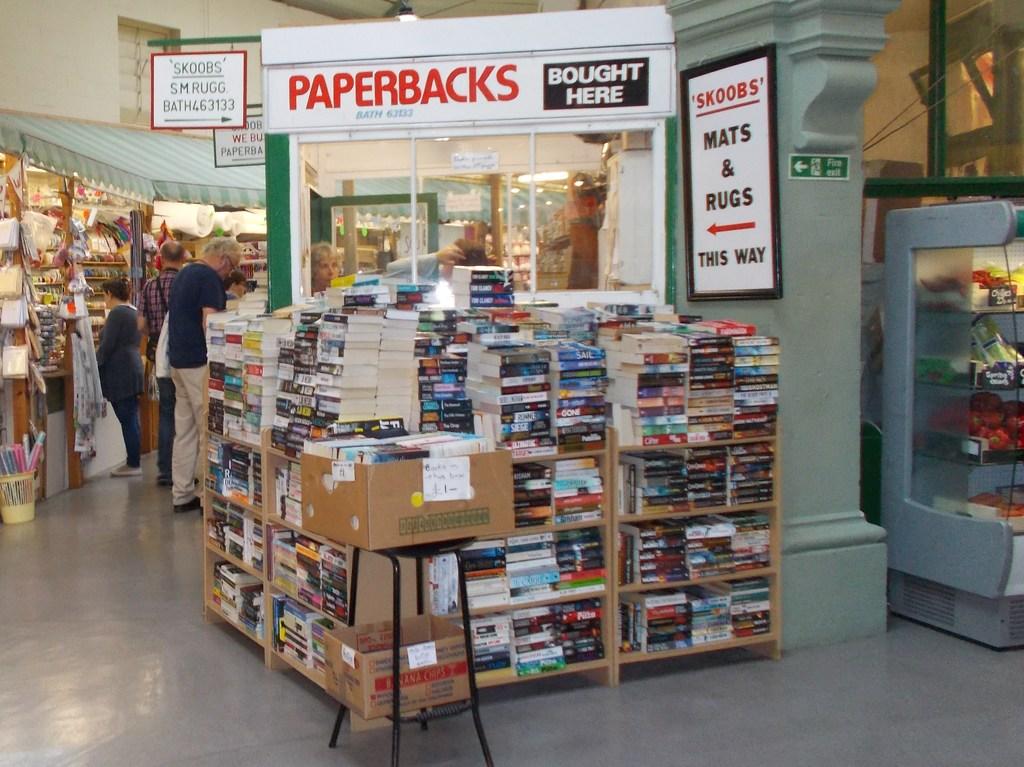What types of books are these?
Offer a terse response. Paperbacks. What type of books are these?
Your answer should be very brief. Paperbacks. 